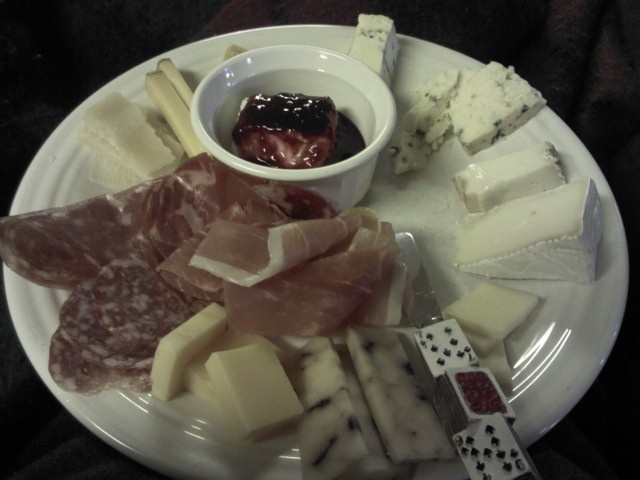Describe the objects in this image and their specific colors. I can see dining table in black, gray, and darkgray tones, bowl in black, darkgray, gray, and beige tones, knife in black and gray tones, and knife in black and gray tones in this image. 